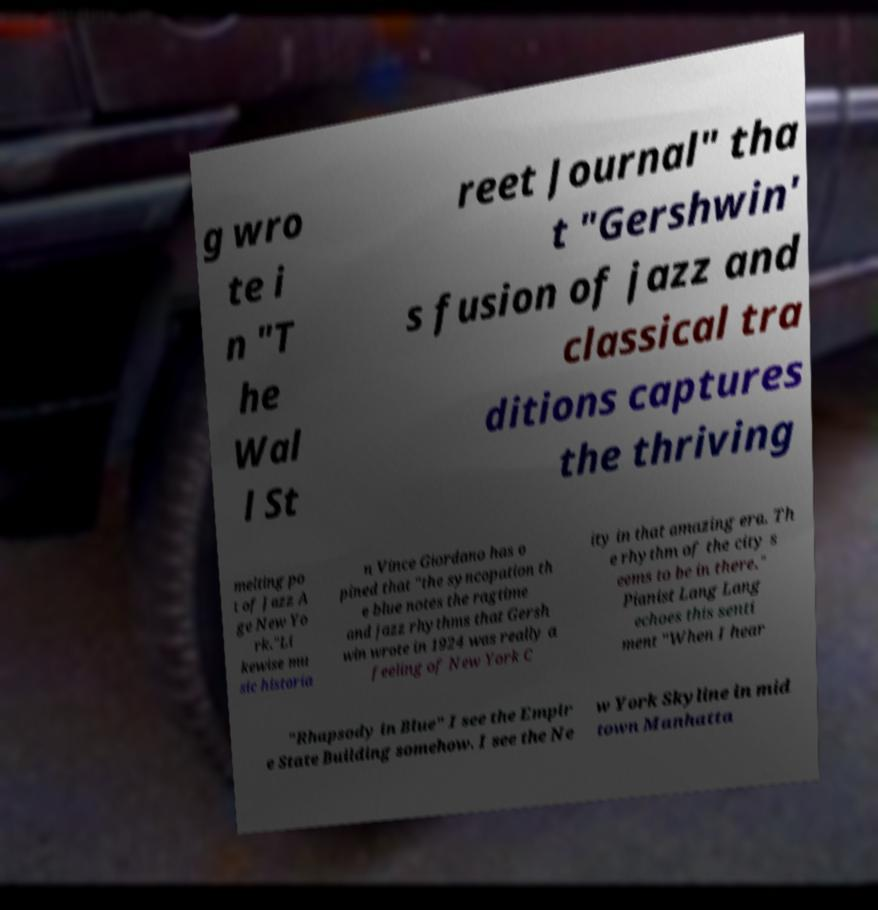Please identify and transcribe the text found in this image. g wro te i n "T he Wal l St reet Journal" tha t "Gershwin' s fusion of jazz and classical tra ditions captures the thriving melting po t of Jazz A ge New Yo rk."Li kewise mu sic historia n Vince Giordano has o pined that "the syncopation th e blue notes the ragtime and jazz rhythms that Gersh win wrote in 1924 was really a feeling of New York C ity in that amazing era. Th e rhythm of the city s eems to be in there." Pianist Lang Lang echoes this senti ment "When I hear "Rhapsody in Blue" I see the Empir e State Building somehow. I see the Ne w York Skyline in mid town Manhatta 